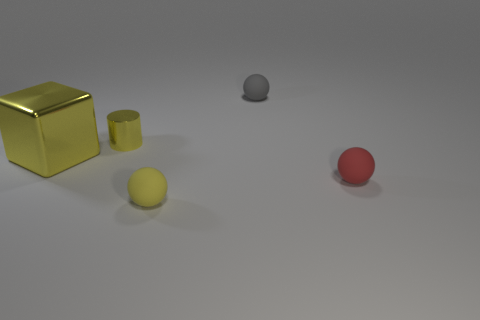What number of yellow metal objects are the same size as the yellow sphere?
Your response must be concise. 1. What is the color of the large object that is made of the same material as the cylinder?
Your answer should be compact. Yellow. Is the number of tiny gray matte cylinders greater than the number of yellow rubber balls?
Keep it short and to the point. No. Is the material of the small gray ball the same as the cube?
Make the answer very short. No. The thing that is the same material as the big yellow block is what shape?
Keep it short and to the point. Cylinder. Are there fewer gray blocks than red rubber spheres?
Give a very brief answer. Yes. What is the tiny object that is both in front of the cube and on the left side of the tiny gray ball made of?
Offer a terse response. Rubber. How big is the matte sphere that is behind the tiny yellow object left of the yellow sphere that is right of the big yellow metal cube?
Your answer should be very brief. Small. There is a gray rubber thing; does it have the same shape as the metal thing in front of the small yellow shiny thing?
Offer a terse response. No. What number of things are left of the small yellow metal cylinder and to the right of the small yellow ball?
Your response must be concise. 0. 